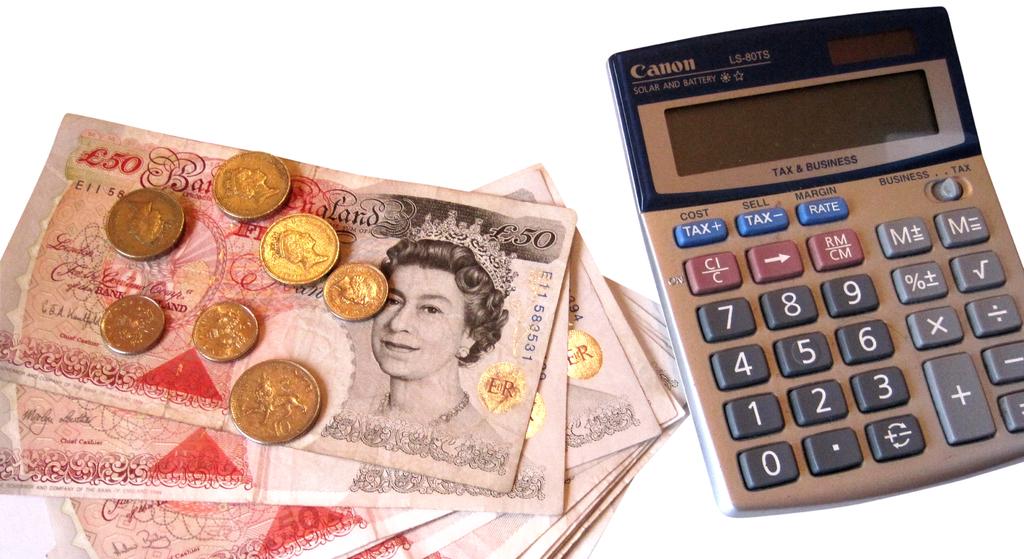What brand is the calculator?
Offer a terse response. Canon. What's the serial number on the top monetary note?
Offer a terse response. E11583531. 